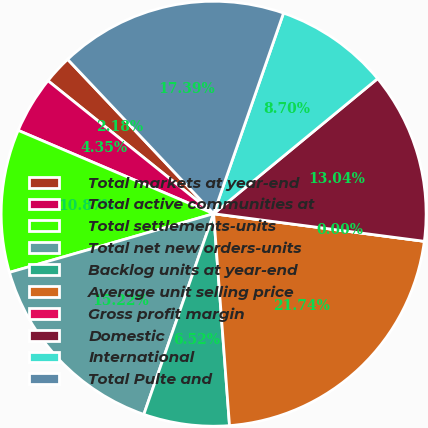Convert chart. <chart><loc_0><loc_0><loc_500><loc_500><pie_chart><fcel>Total markets at year-end<fcel>Total active communities at<fcel>Total settlements-units<fcel>Total net new orders-units<fcel>Backlog units at year-end<fcel>Average unit selling price<fcel>Gross profit margin<fcel>Domestic<fcel>International<fcel>Total Pulte and<nl><fcel>2.18%<fcel>4.35%<fcel>10.87%<fcel>15.22%<fcel>6.52%<fcel>21.74%<fcel>0.0%<fcel>13.04%<fcel>8.7%<fcel>17.39%<nl></chart> 